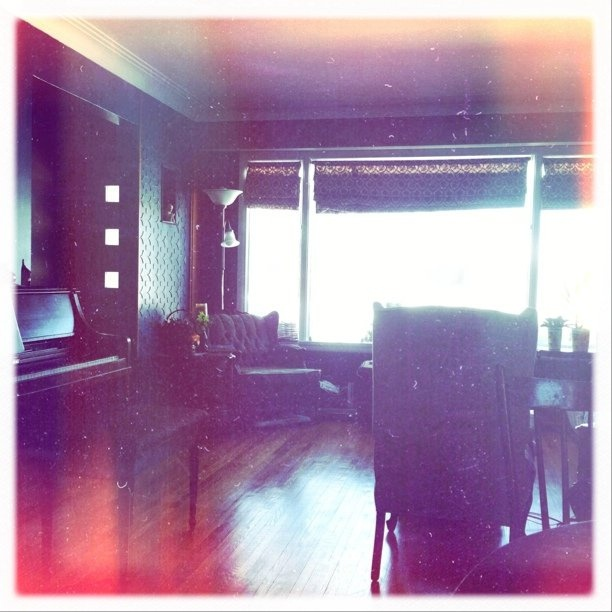Describe the objects in this image and their specific colors. I can see chair in white, purple, and darkgray tones, couch in white and purple tones, chair in white and purple tones, dining table in white and purple tones, and tv in white, purple, and lightblue tones in this image. 